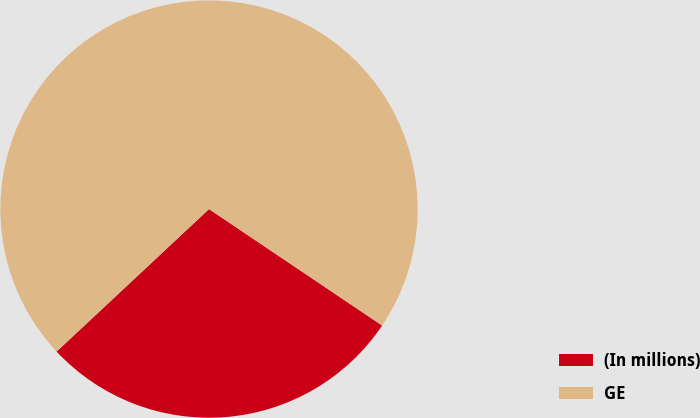<chart> <loc_0><loc_0><loc_500><loc_500><pie_chart><fcel>(In millions)<fcel>GE<nl><fcel>28.61%<fcel>71.39%<nl></chart> 